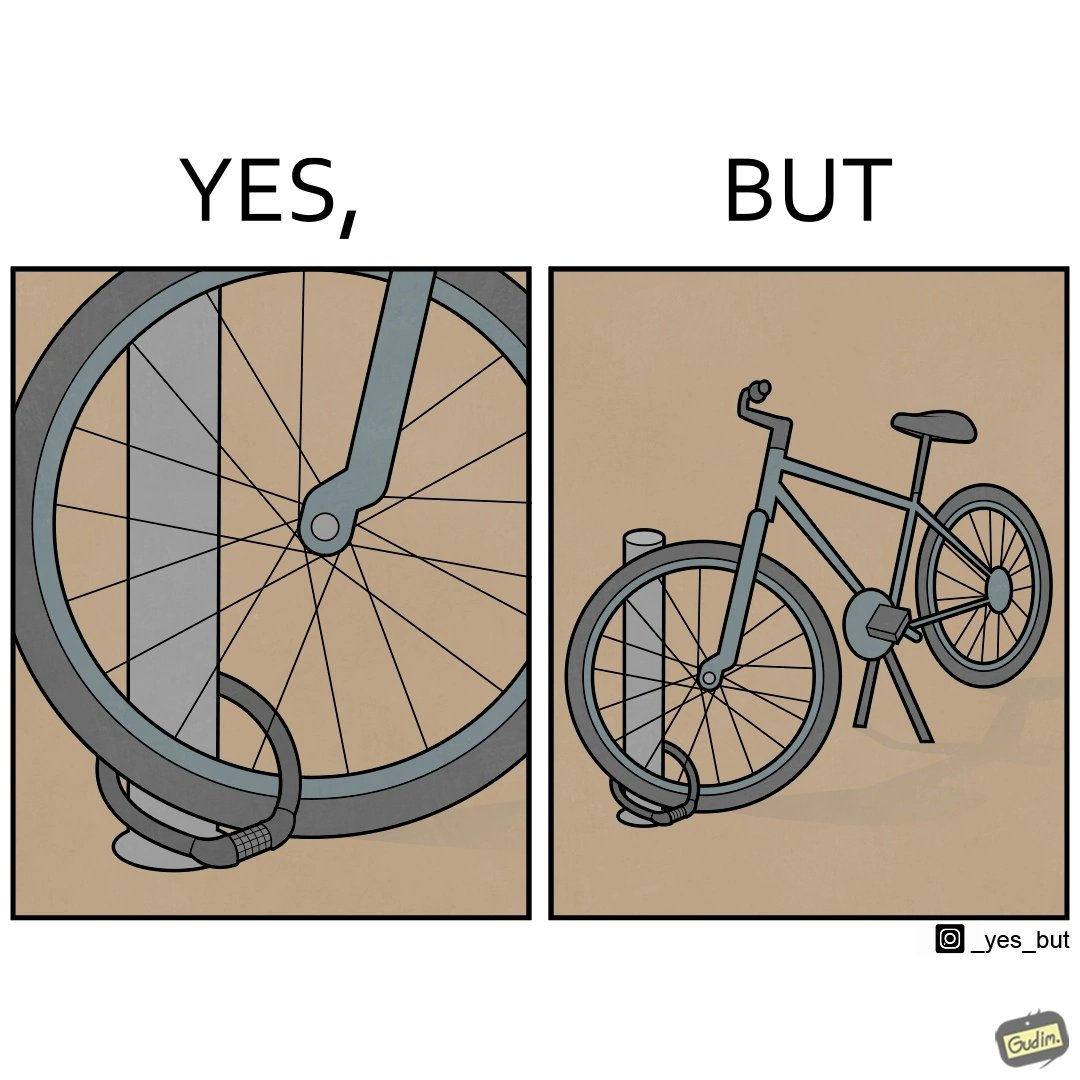Describe what you see in the left and right parts of this image. In the left part of the image: a wheel locked with a bike lock on a poll In the right part of the image: a bicycle locked on a pole 